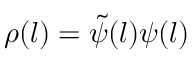Convert formula to latex. <formula><loc_0><loc_0><loc_500><loc_500>\rho ( l ) = \tilde { \psi } ( l ) \psi ( l )</formula> 